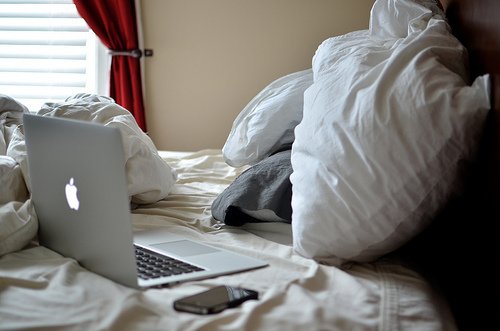<image>
Is there a phone to the left of the laptop? Yes. From this viewpoint, the phone is positioned to the left side relative to the laptop. 